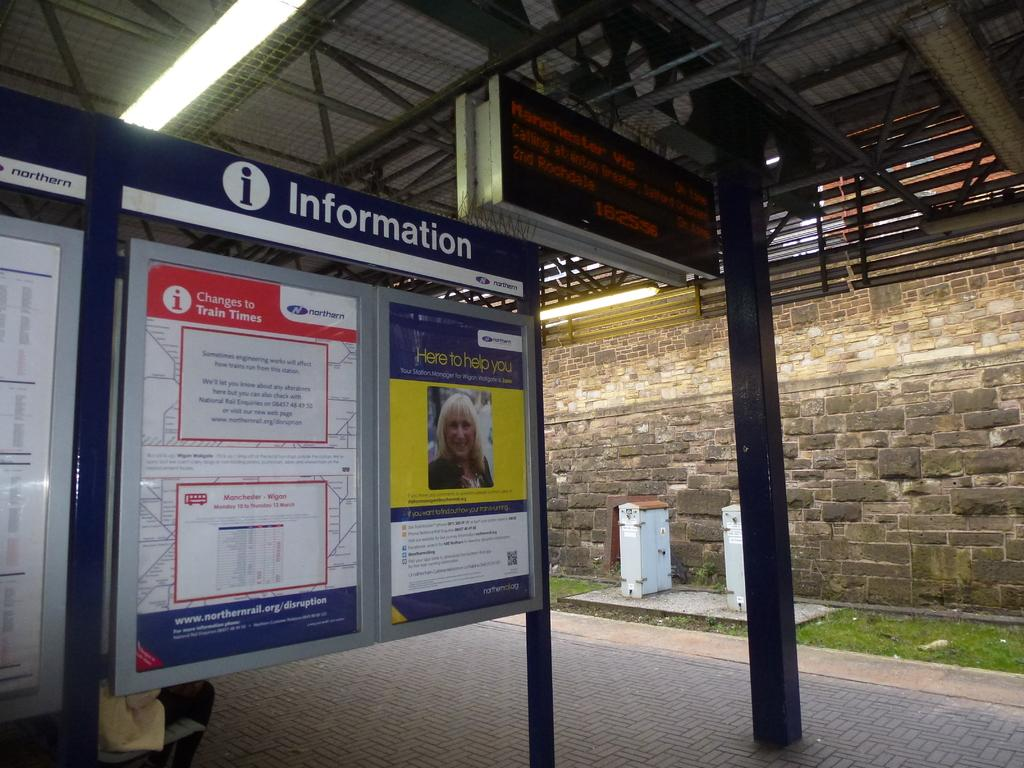<image>
Give a short and clear explanation of the subsequent image. A large sign gives information including about changes to train times. 